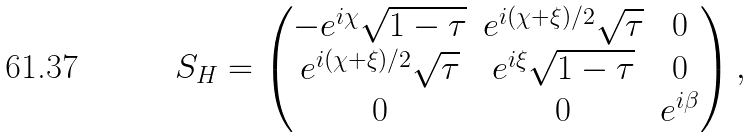Convert formula to latex. <formula><loc_0><loc_0><loc_500><loc_500>S _ { H } = \begin{pmatrix} - e ^ { i \chi } \sqrt { 1 - \tau } & e ^ { i ( \chi + \xi ) / 2 } \sqrt { \tau } & 0 \\ e ^ { i ( \chi + \xi ) / 2 } \sqrt { \tau } & e ^ { i \xi } \sqrt { 1 - \tau } & 0 \\ 0 & 0 & e ^ { i \beta } \end{pmatrix} ,</formula> 